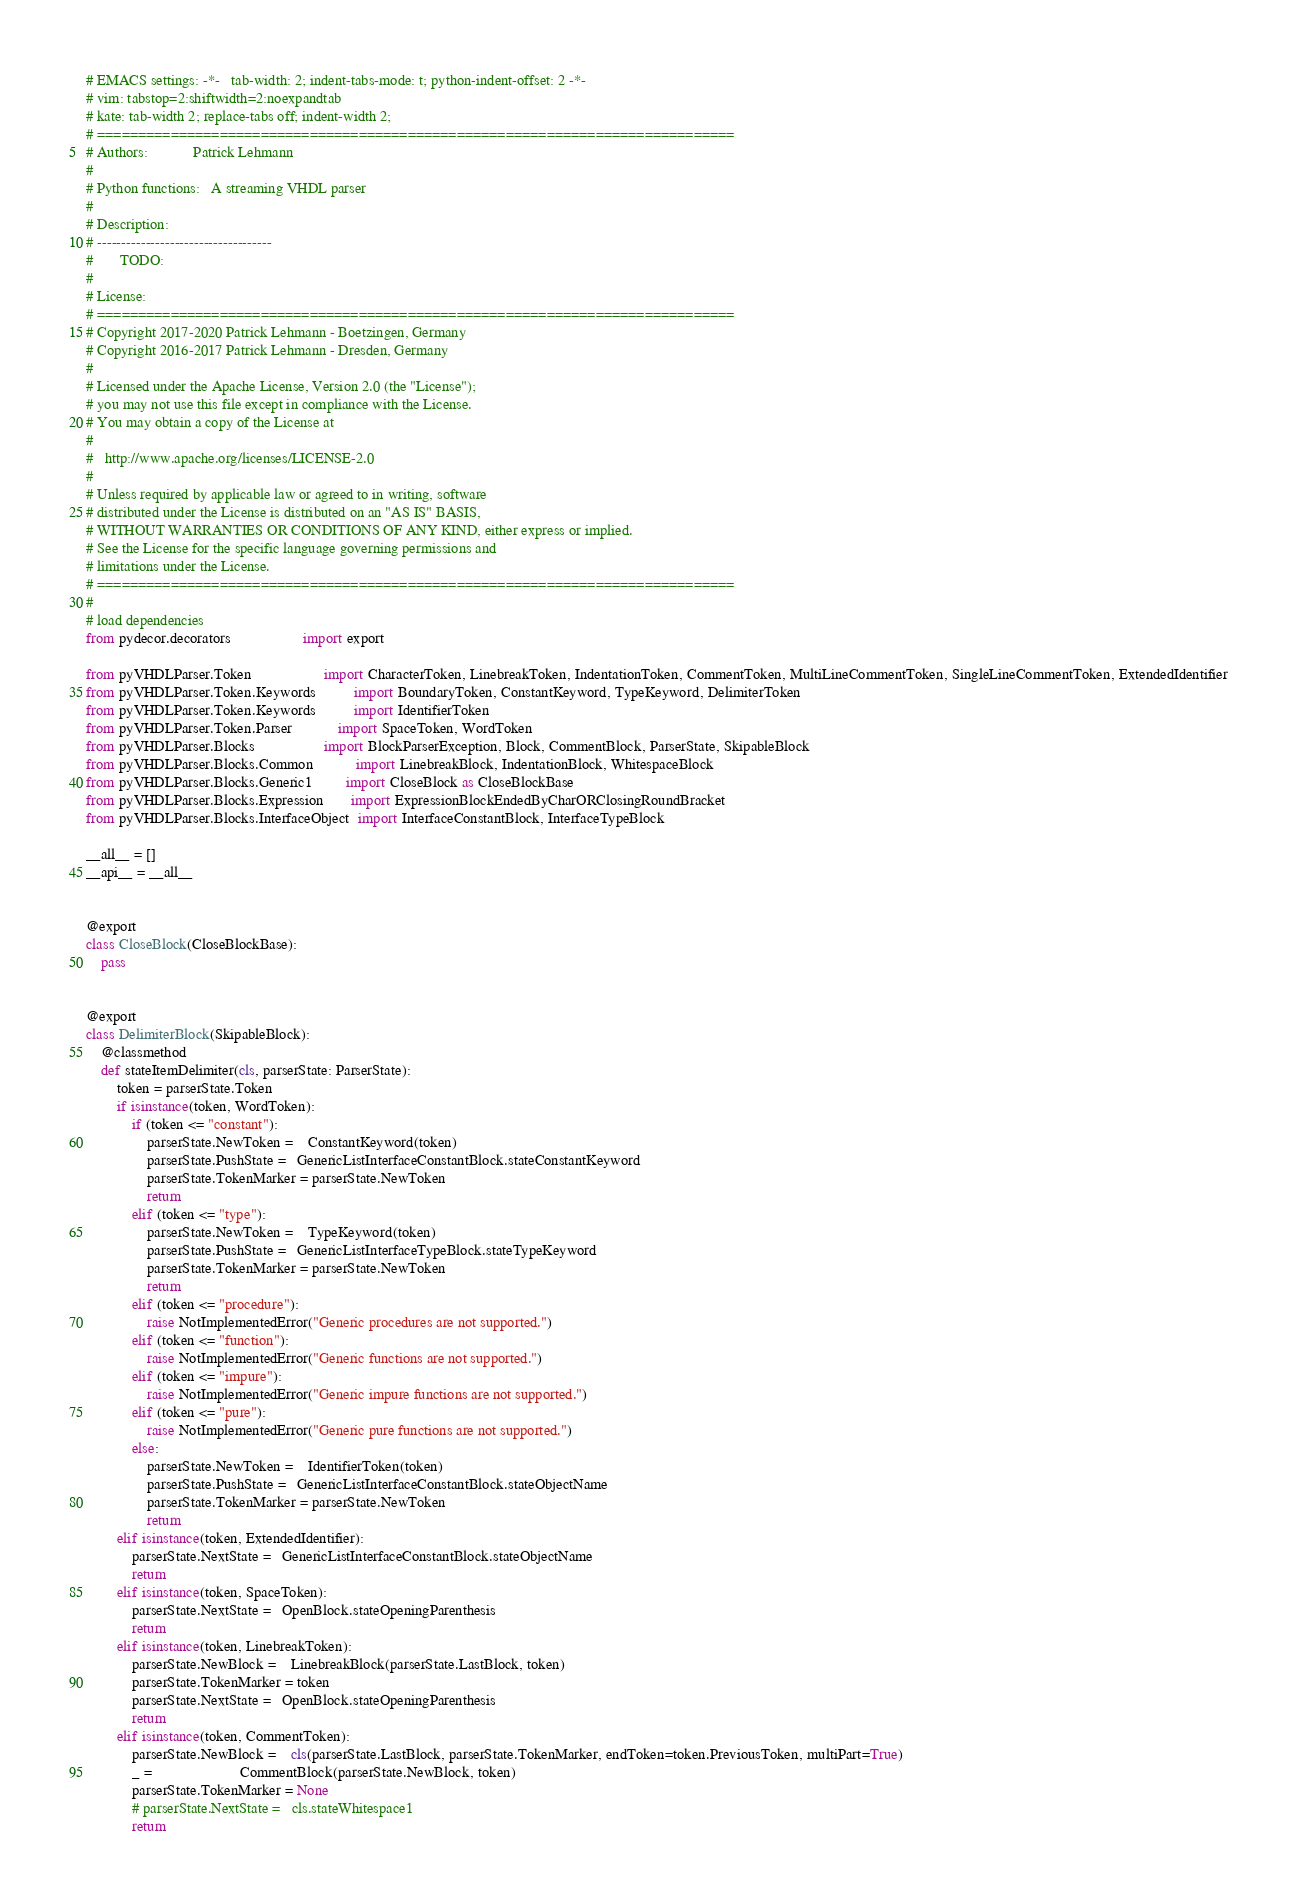<code> <loc_0><loc_0><loc_500><loc_500><_Python_># EMACS settings: -*-	tab-width: 2; indent-tabs-mode: t; python-indent-offset: 2 -*-
# vim: tabstop=2:shiftwidth=2:noexpandtab
# kate: tab-width 2; replace-tabs off; indent-width 2;
# ==============================================================================
# Authors:            Patrick Lehmann
#
# Python functions:   A streaming VHDL parser
#
# Description:
# ------------------------------------
#		TODO:
#
# License:
# ==============================================================================
# Copyright 2017-2020 Patrick Lehmann - Boetzingen, Germany
# Copyright 2016-2017 Patrick Lehmann - Dresden, Germany
#
# Licensed under the Apache License, Version 2.0 (the "License");
# you may not use this file except in compliance with the License.
# You may obtain a copy of the License at
#
#   http://www.apache.org/licenses/LICENSE-2.0
#
# Unless required by applicable law or agreed to in writing, software
# distributed under the License is distributed on an "AS IS" BASIS,
# WITHOUT WARRANTIES OR CONDITIONS OF ANY KIND, either express or implied.
# See the License for the specific language governing permissions and
# limitations under the License.
# ==============================================================================
#
# load dependencies
from pydecor.decorators                   import export

from pyVHDLParser.Token                   import CharacterToken, LinebreakToken, IndentationToken, CommentToken, MultiLineCommentToken, SingleLineCommentToken, ExtendedIdentifier
from pyVHDLParser.Token.Keywords          import BoundaryToken, ConstantKeyword, TypeKeyword, DelimiterToken
from pyVHDLParser.Token.Keywords          import IdentifierToken
from pyVHDLParser.Token.Parser            import SpaceToken, WordToken
from pyVHDLParser.Blocks                  import BlockParserException, Block, CommentBlock, ParserState, SkipableBlock
from pyVHDLParser.Blocks.Common           import LinebreakBlock, IndentationBlock, WhitespaceBlock
from pyVHDLParser.Blocks.Generic1         import CloseBlock as CloseBlockBase
from pyVHDLParser.Blocks.Expression       import ExpressionBlockEndedByCharORClosingRoundBracket
from pyVHDLParser.Blocks.InterfaceObject  import InterfaceConstantBlock, InterfaceTypeBlock

__all__ = []
__api__ = __all__


@export
class CloseBlock(CloseBlockBase):
	pass


@export
class DelimiterBlock(SkipableBlock):
	@classmethod
	def stateItemDelimiter(cls, parserState: ParserState):
		token = parserState.Token
		if isinstance(token, WordToken):
			if (token <= "constant"):
				parserState.NewToken =    ConstantKeyword(token)
				parserState.PushState =   GenericListInterfaceConstantBlock.stateConstantKeyword
				parserState.TokenMarker = parserState.NewToken
				return
			elif (token <= "type"):
				parserState.NewToken =    TypeKeyword(token)
				parserState.PushState =   GenericListInterfaceTypeBlock.stateTypeKeyword
				parserState.TokenMarker = parserState.NewToken
				return
			elif (token <= "procedure"):
				raise NotImplementedError("Generic procedures are not supported.")
			elif (token <= "function"):
				raise NotImplementedError("Generic functions are not supported.")
			elif (token <= "impure"):
				raise NotImplementedError("Generic impure functions are not supported.")
			elif (token <= "pure"):
				raise NotImplementedError("Generic pure functions are not supported.")
			else:
				parserState.NewToken =    IdentifierToken(token)
				parserState.PushState =   GenericListInterfaceConstantBlock.stateObjectName
				parserState.TokenMarker = parserState.NewToken
				return
		elif isinstance(token, ExtendedIdentifier):
			parserState.NextState =   GenericListInterfaceConstantBlock.stateObjectName
			return
		elif isinstance(token, SpaceToken):
			parserState.NextState =   OpenBlock.stateOpeningParenthesis
			return
		elif isinstance(token, LinebreakToken):
			parserState.NewBlock =    LinebreakBlock(parserState.LastBlock, token)
			parserState.TokenMarker = token
			parserState.NextState =   OpenBlock.stateOpeningParenthesis
			return
		elif isinstance(token, CommentToken):
			parserState.NewBlock =    cls(parserState.LastBlock, parserState.TokenMarker, endToken=token.PreviousToken, multiPart=True)
			_ =                       CommentBlock(parserState.NewBlock, token)
			parserState.TokenMarker = None
			# parserState.NextState =   cls.stateWhitespace1
			return
</code> 